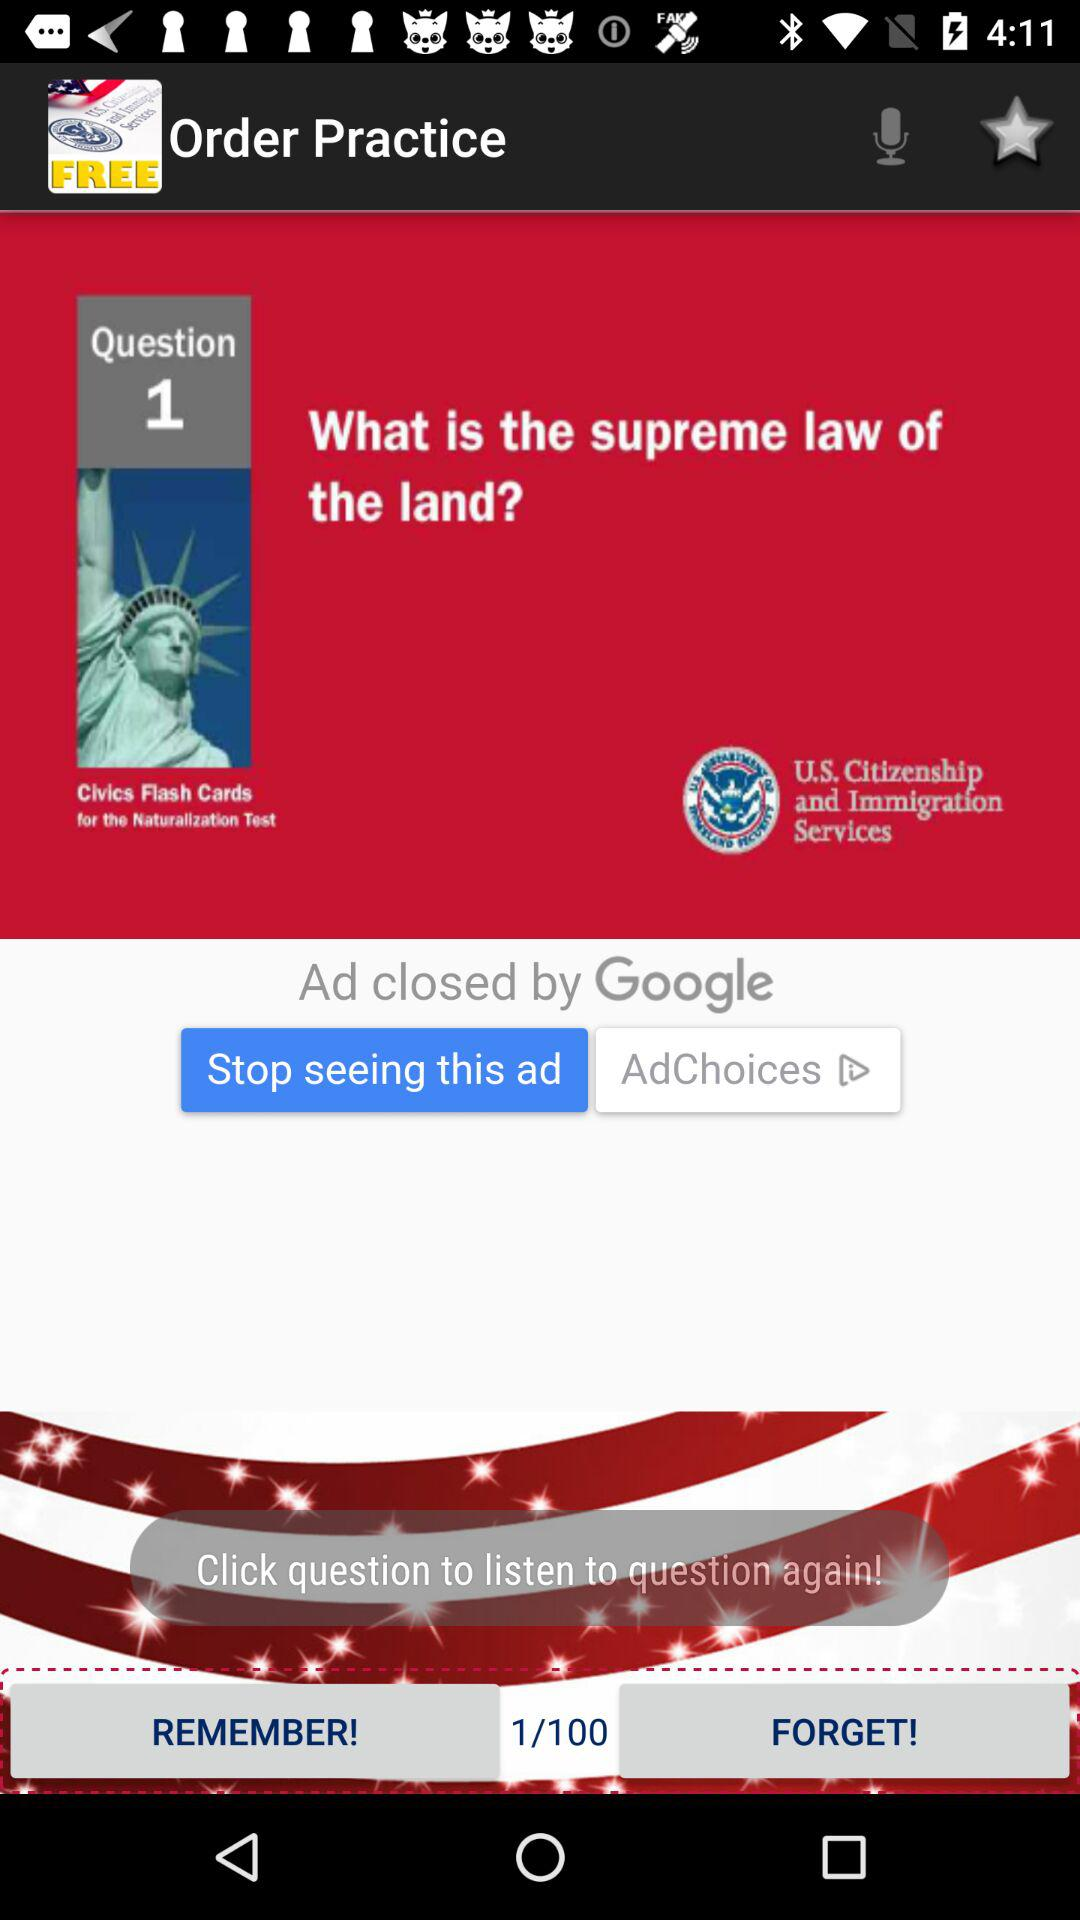Which question am I on? You are on question 1. 